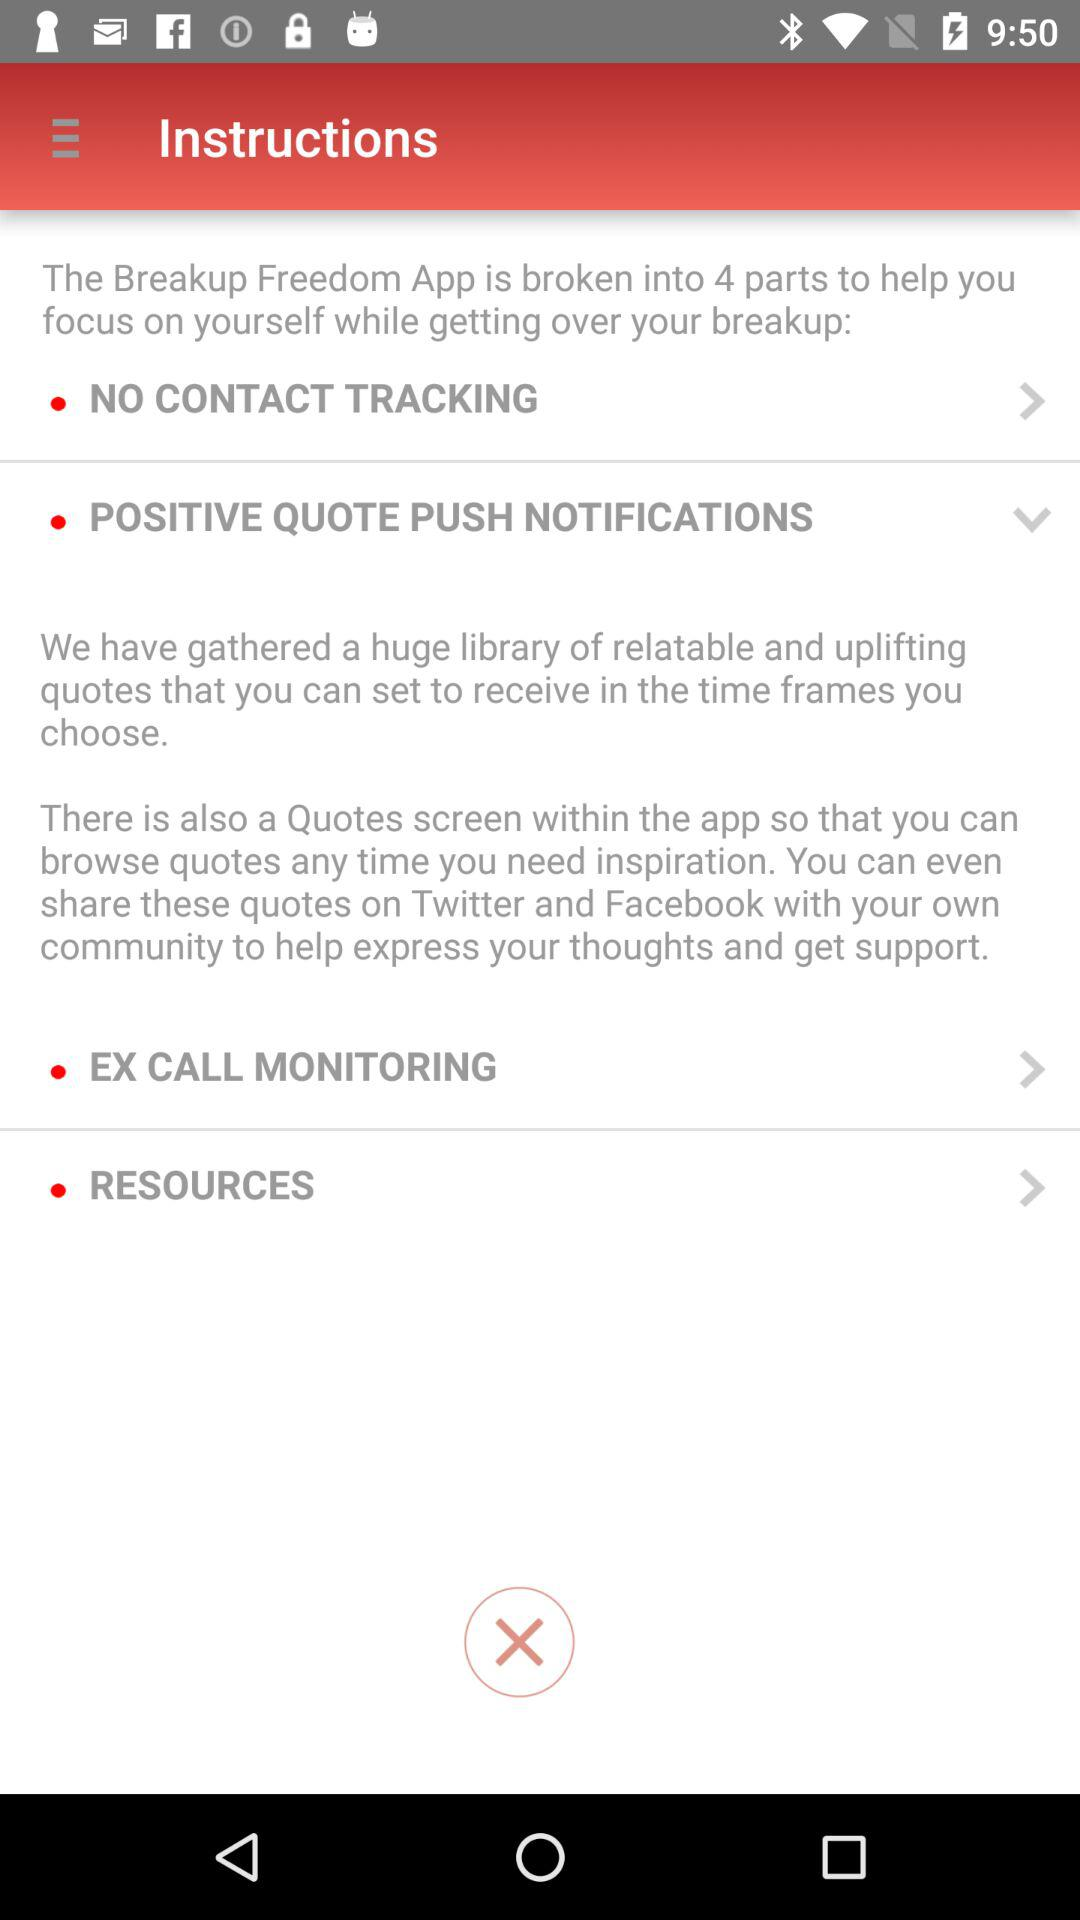What is the name of the application? The name of the application is "Breakup Freedom". 